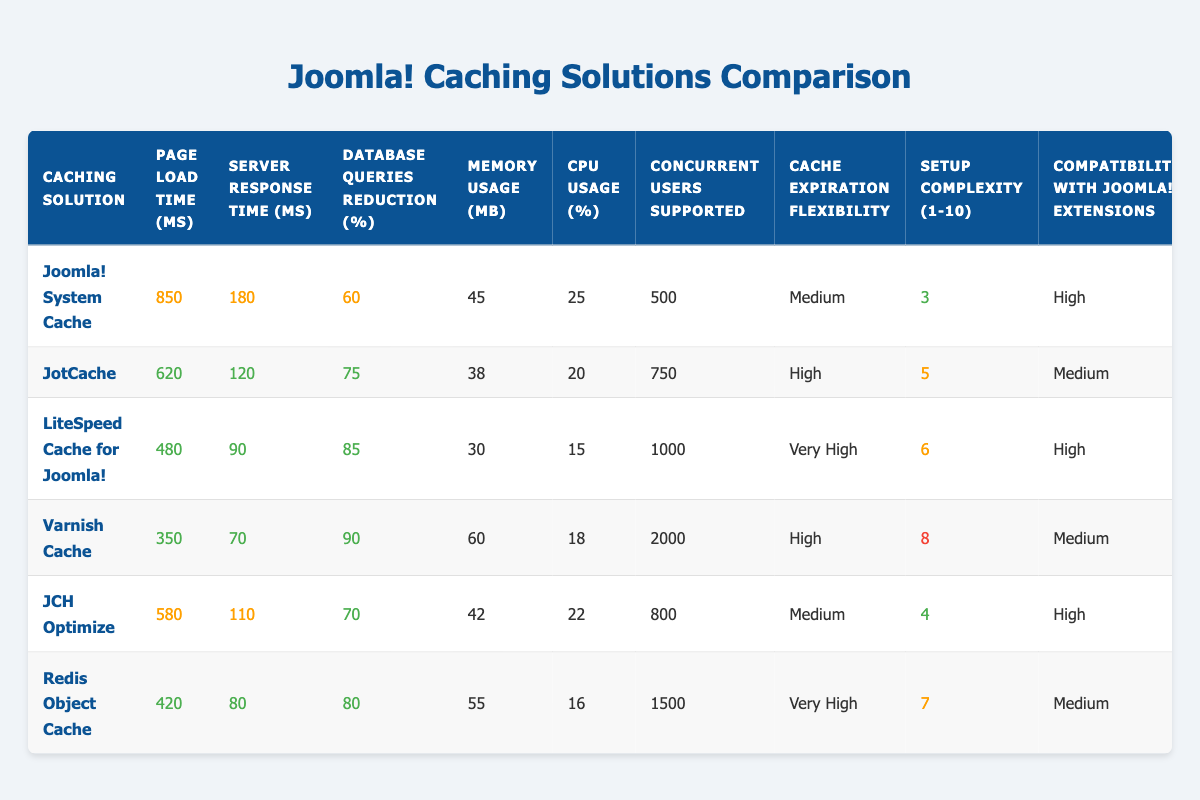What is the page load time for Varnish Cache? The page load time for Varnish Cache is listed directly in the table under the "Page Load Time (ms)" column for Varnish Cache, which shows 350 ms.
Answer: 350 ms How much is the database queries reduction percentage for LiteSpeed Cache for Joomla!? In the table, the database queries reduction percentage for LiteSpeed Cache for Joomla! can be found under the "Database Queries Reduction (%)" column. The value is 85%.
Answer: 85% Which caching solution supports the highest number of concurrent users? To find the highest supported concurrent users, I examine the "Concurrent Users Supported" column and see the values. Varnish Cache has the highest value of 2000 concurrent users.
Answer: 2000 What is the average server response time among all caching solutions? I will calculate the average server response time. Adding all server response times: 180 + 120 + 90 + 70 + 110 + 80 = 650 ms. Then dividing by the number of solutions (6): 650 / 6 = approximately 108.33 ms.
Answer: Approximately 108.33 ms Does JotCache have a higher CPU usage percentage than Joomla! System Cache? I compare the "CPU Usage (%)" values for both caching solutions: JotCache shows 20% and Joomla! System Cache shows 25%. Since 20% is less than 25%, the statement is false.
Answer: No What caching solution has the lowest memory usage? Looking at the "Memory Usage (MB)" column, I compare all values: 45 (Joomla! System Cache), 38 (JotCache), 30 (LiteSpeed Cache for Joomla!), 60 (Varnish Cache), 42 (JCH Optimize), and 55 (Redis Object Cache). JotCache has the lowest value at 38 MB.
Answer: JotCache Is the setup complexity of Varnish Cache greater than that of LiteSpeed Cache for Joomla!? I need to check the "Setup Complexity (1-10)" values for both caching solutions: Varnish Cache has a score of 8, while LiteSpeed Cache for Joomla! has a score of 6. Since 8 is greater than 6, the statement is true.
Answer: Yes How many caching solutions have high compatibility with Joomla! extensions? In the table under "Compatibility with Joomla! Extensions", examining the entries shows 4 caching solutions (Joomla! System Cache, LiteSpeed Cache for Joomla!, JCH Optimize) have high compatibility, while the others do not.
Answer: 3 What is the difference in database queries reduction percentage between Varnish Cache and Redis Object Cache? I look up the "Database Queries Reduction (%)" values for both: Varnish Cache is 90% and Redis Object Cache is 80%. The difference is 90 - 80 = 10%.
Answer: 10% 